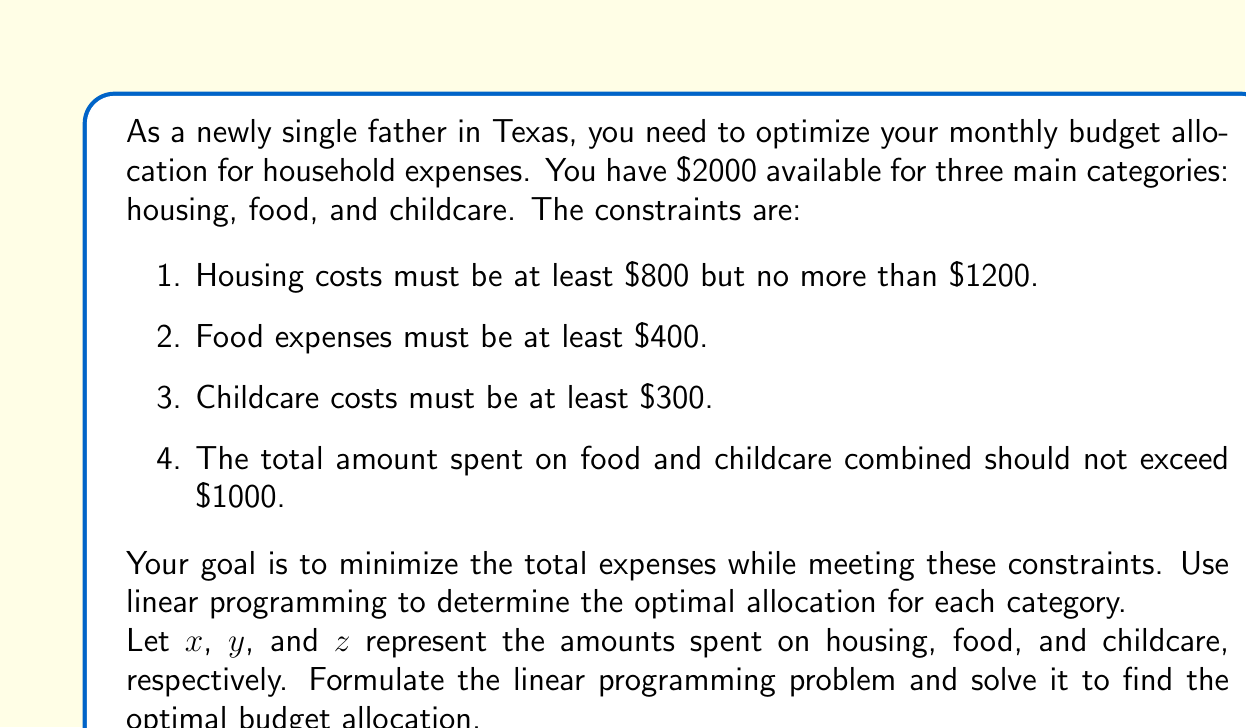Show me your answer to this math problem. To solve this problem using linear programming, we need to formulate the objective function and constraints, then solve the resulting system.

1. Objective function:
   Minimize $f(x, y, z) = x + y + z$

2. Constraints:
   a) $800 \leq x \leq 1200$
   b) $y \geq 400$
   c) $z \geq 300$
   d) $y + z \leq 1000$
   e) $x + y + z \leq 2000$

3. Non-negativity constraints:
   $x, y, z \geq 0$

To solve this linear programming problem, we can use the simplex method or a graphical approach. In this case, we'll use a logical approach based on the constraints.

Step 1: Analyze the constraints
- Housing (x) must be between $800 and $1200
- Food (y) and childcare (z) must sum to at most $1000
- The total budget is $2000

Step 2: Minimize housing costs
Since we want to minimize total expenses, we should set housing costs to the minimum allowed:
$x = 800$

Step 3: Allocate remaining budget to food and childcare
Remaining budget = $2000 - $800 = $1200

Step 4: Meet minimum requirements for food and childcare
- Minimum for food: $y = 400$
- Minimum for childcare: $z = 300$

Step 5: Allocate any remaining funds
Remaining funds = $1200 - $400 - $300 = $500

We can allocate this $500 to either food or childcare, keeping in mind that their sum should not exceed $1000. To minimize expenses, we should not allocate more than necessary.

Therefore, the optimal allocation is:
- Housing (x): $800
- Food (y): $400
- Childcare (z): $300

Total expenses: $800 + $400 + $300 = $1500

This solution satisfies all constraints and minimizes the total expenses.
Answer: The optimal budget allocation is:
Housing: $800
Food: $400
Childcare: $300
Total expenses: $1500 